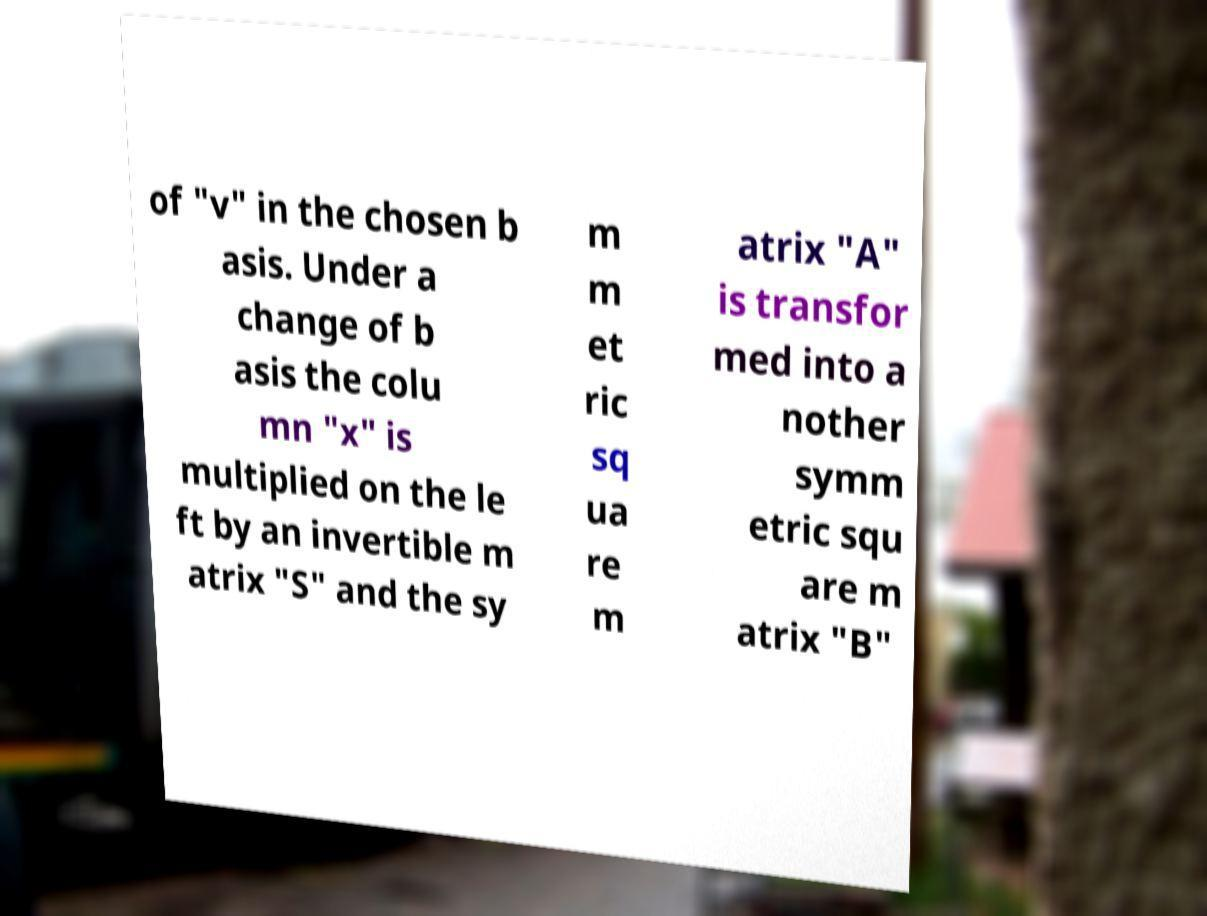Could you assist in decoding the text presented in this image and type it out clearly? of "v" in the chosen b asis. Under a change of b asis the colu mn "x" is multiplied on the le ft by an invertible m atrix "S" and the sy m m et ric sq ua re m atrix "A" is transfor med into a nother symm etric squ are m atrix "B" 